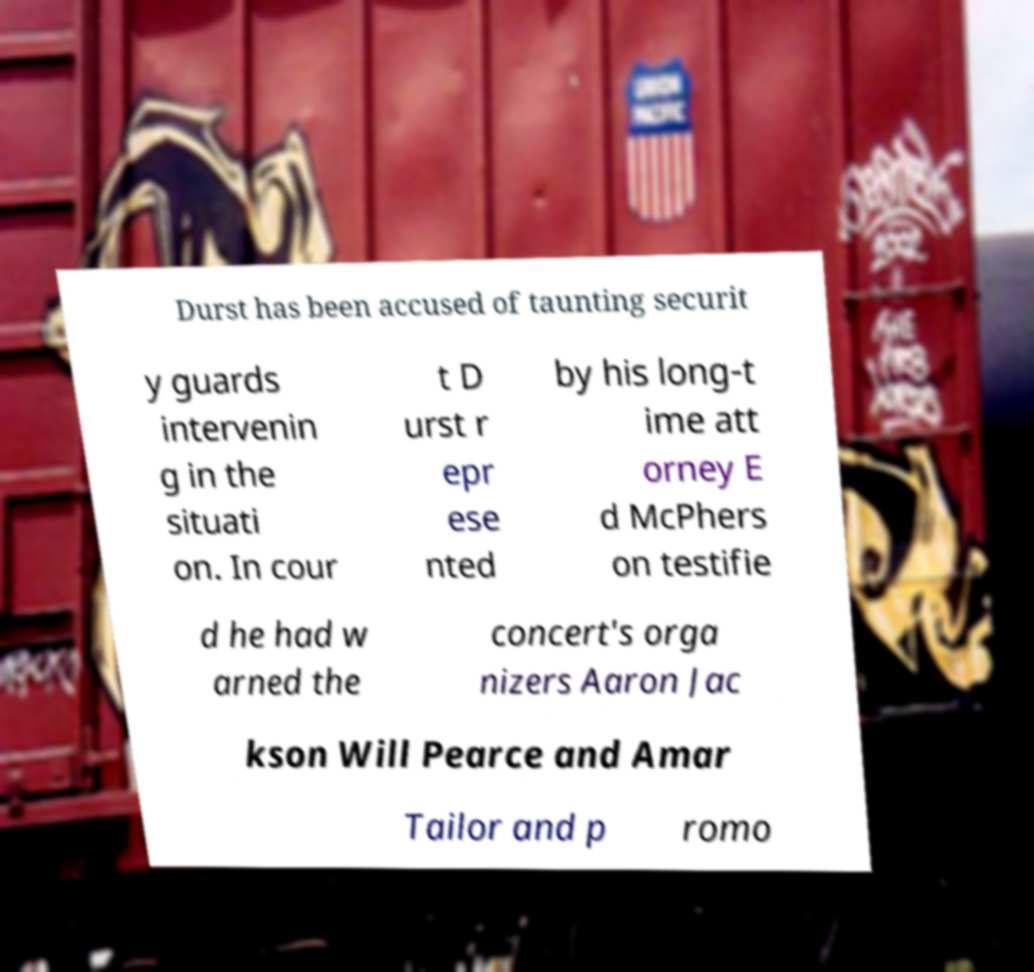Can you accurately transcribe the text from the provided image for me? Durst has been accused of taunting securit y guards intervenin g in the situati on. In cour t D urst r epr ese nted by his long-t ime att orney E d McPhers on testifie d he had w arned the concert's orga nizers Aaron Jac kson Will Pearce and Amar Tailor and p romo 